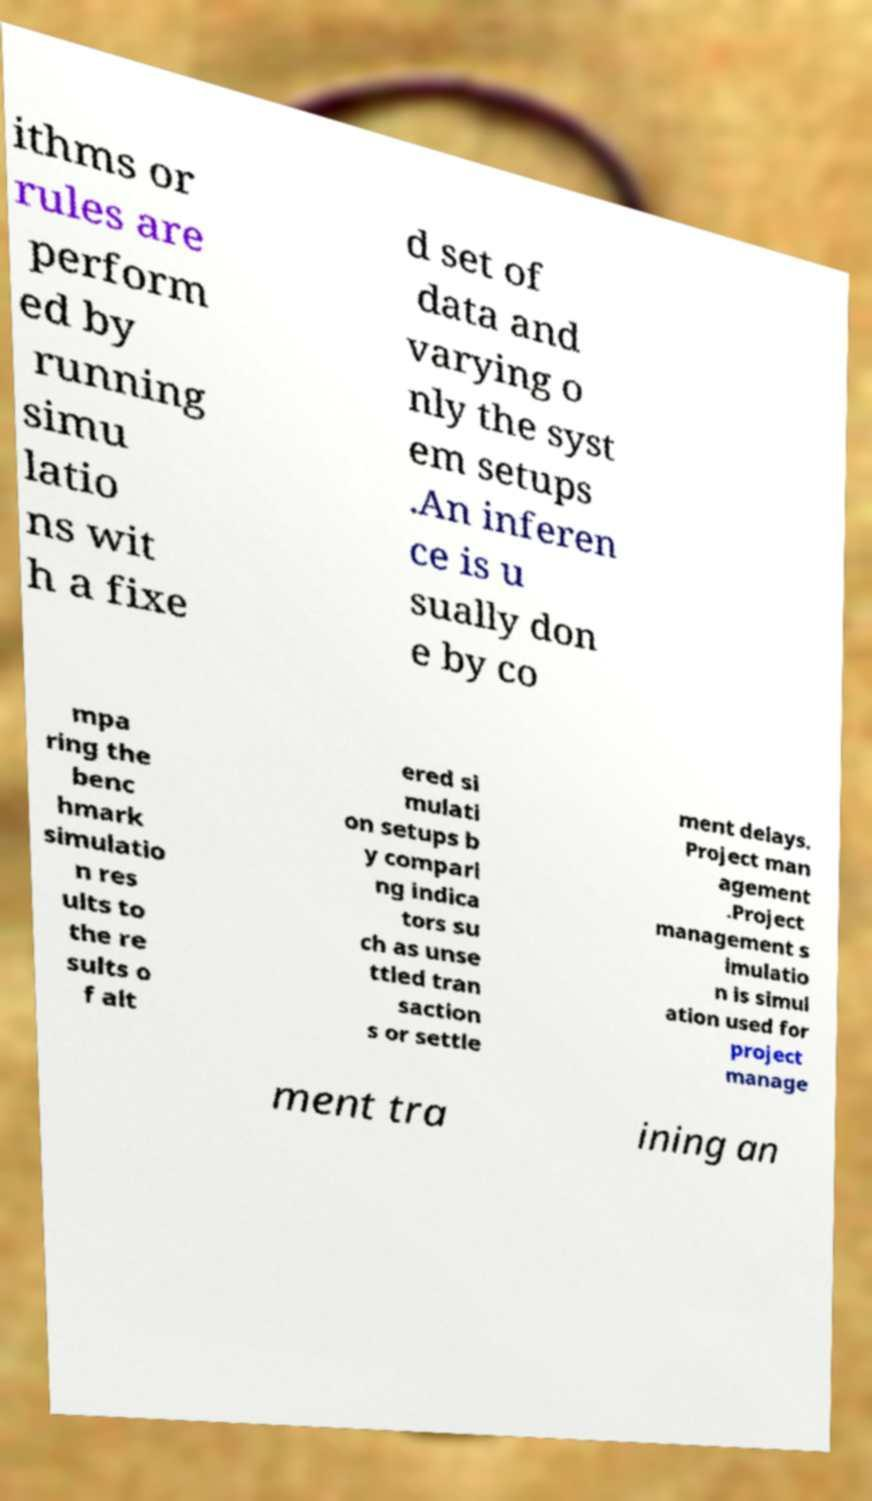Can you read and provide the text displayed in the image?This photo seems to have some interesting text. Can you extract and type it out for me? ithms or rules are perform ed by running simu latio ns wit h a fixe d set of data and varying o nly the syst em setups .An inferen ce is u sually don e by co mpa ring the benc hmark simulatio n res ults to the re sults o f alt ered si mulati on setups b y compari ng indica tors su ch as unse ttled tran saction s or settle ment delays. Project man agement .Project management s imulatio n is simul ation used for project manage ment tra ining an 